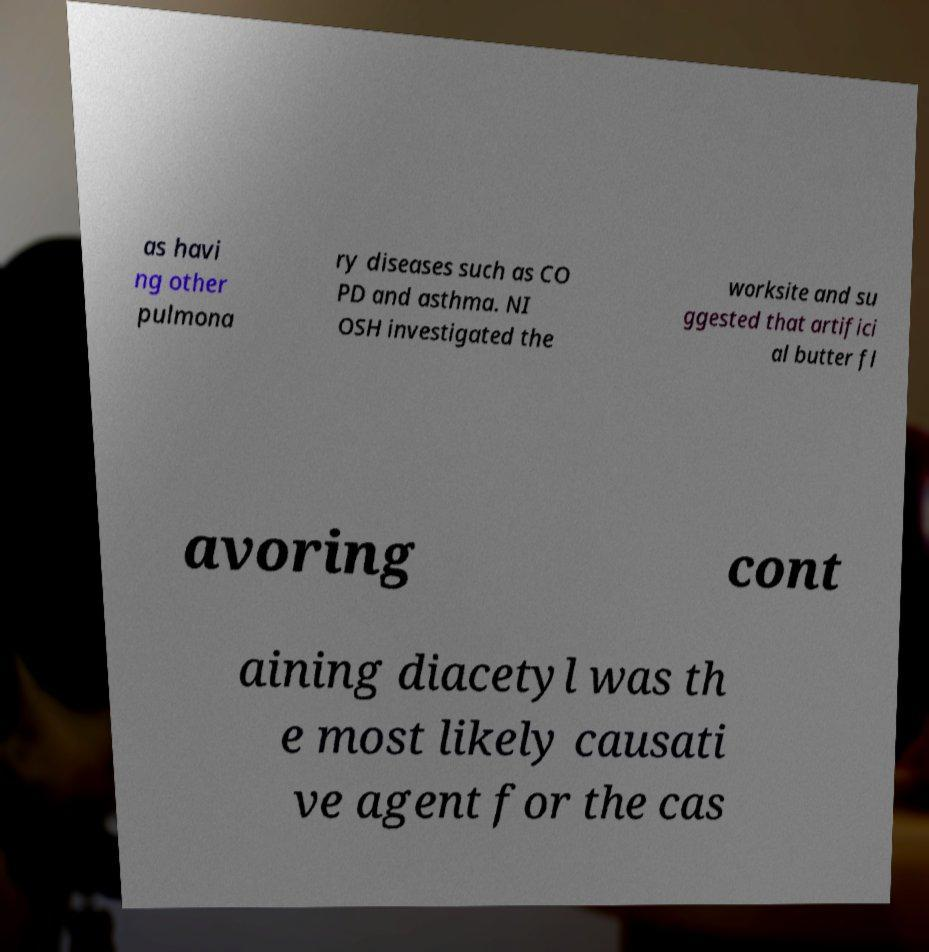There's text embedded in this image that I need extracted. Can you transcribe it verbatim? as havi ng other pulmona ry diseases such as CO PD and asthma. NI OSH investigated the worksite and su ggested that artifici al butter fl avoring cont aining diacetyl was th e most likely causati ve agent for the cas 